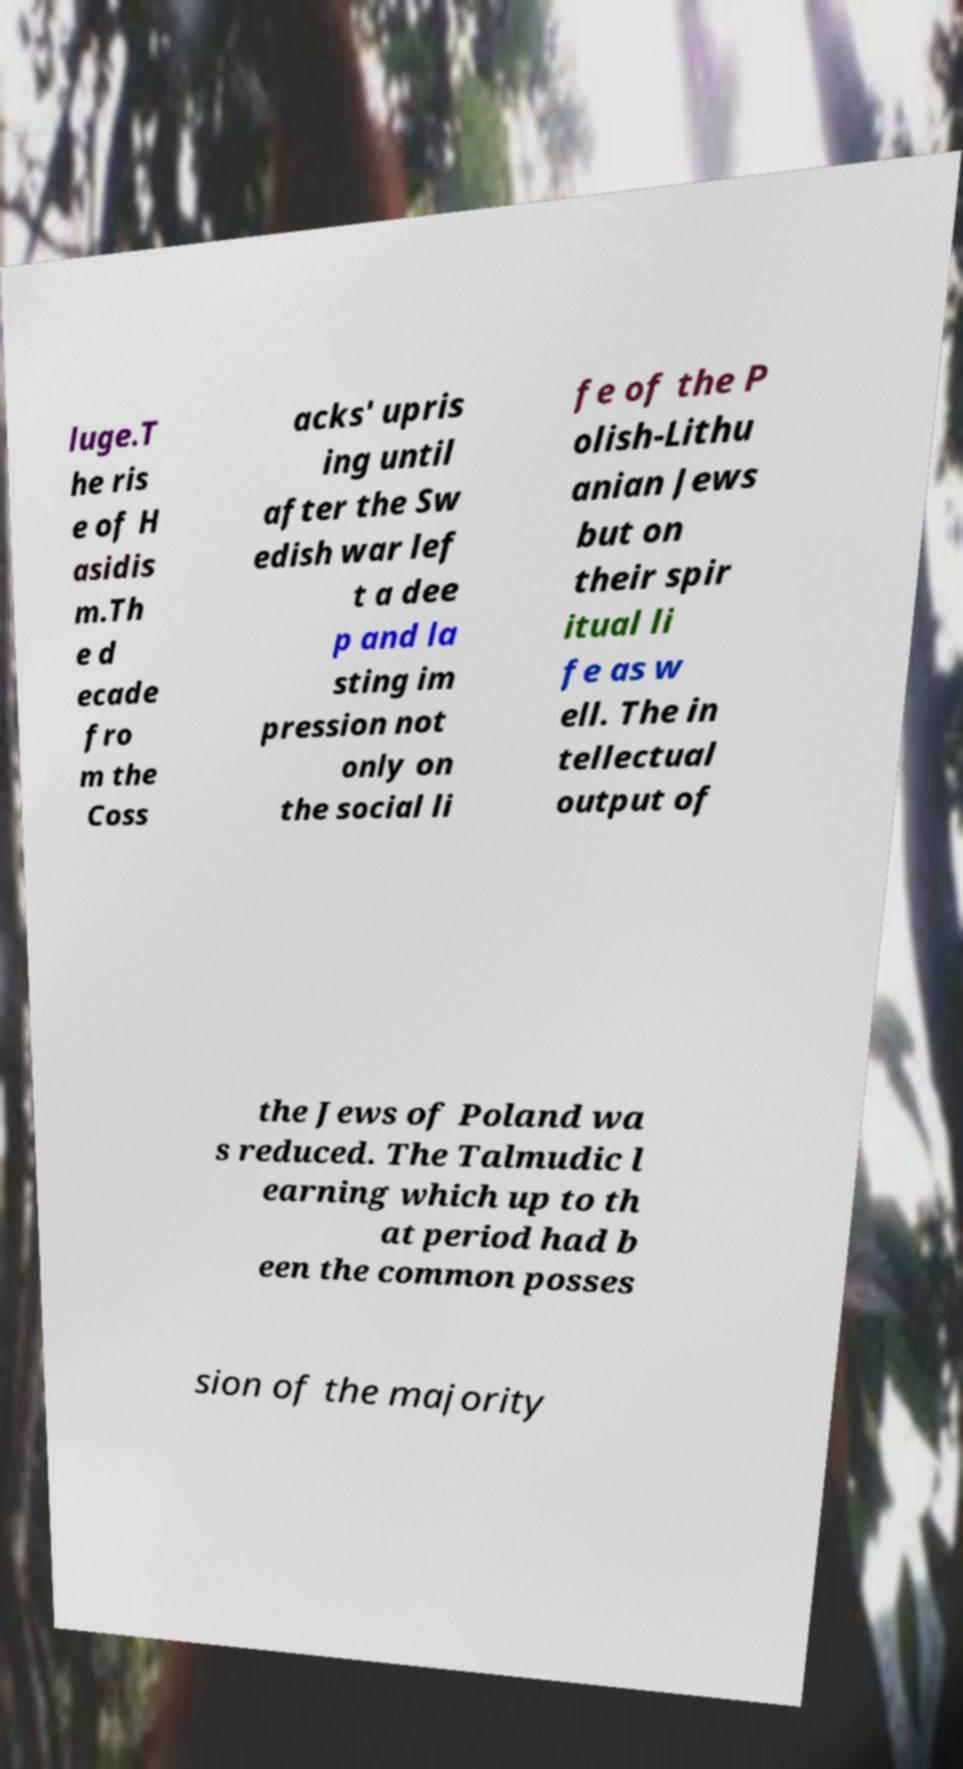Please read and relay the text visible in this image. What does it say? luge.T he ris e of H asidis m.Th e d ecade fro m the Coss acks' upris ing until after the Sw edish war lef t a dee p and la sting im pression not only on the social li fe of the P olish-Lithu anian Jews but on their spir itual li fe as w ell. The in tellectual output of the Jews of Poland wa s reduced. The Talmudic l earning which up to th at period had b een the common posses sion of the majority 